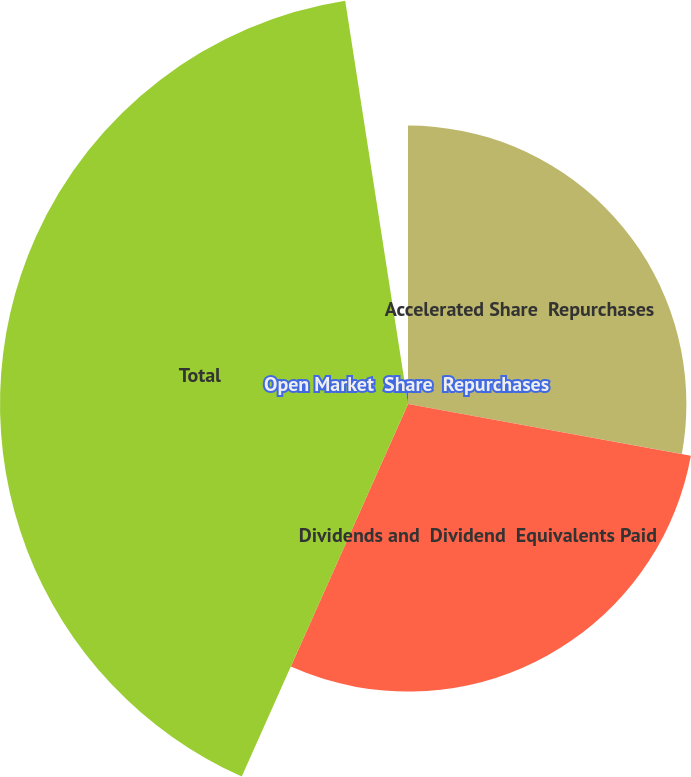Convert chart. <chart><loc_0><loc_0><loc_500><loc_500><pie_chart><fcel>Accelerated Share  Repurchases<fcel>Dividends and  Dividend  Equivalents Paid<fcel>Total<fcel>Open Market  Share  Repurchases<nl><fcel>27.88%<fcel>28.8%<fcel>40.86%<fcel>2.46%<nl></chart> 